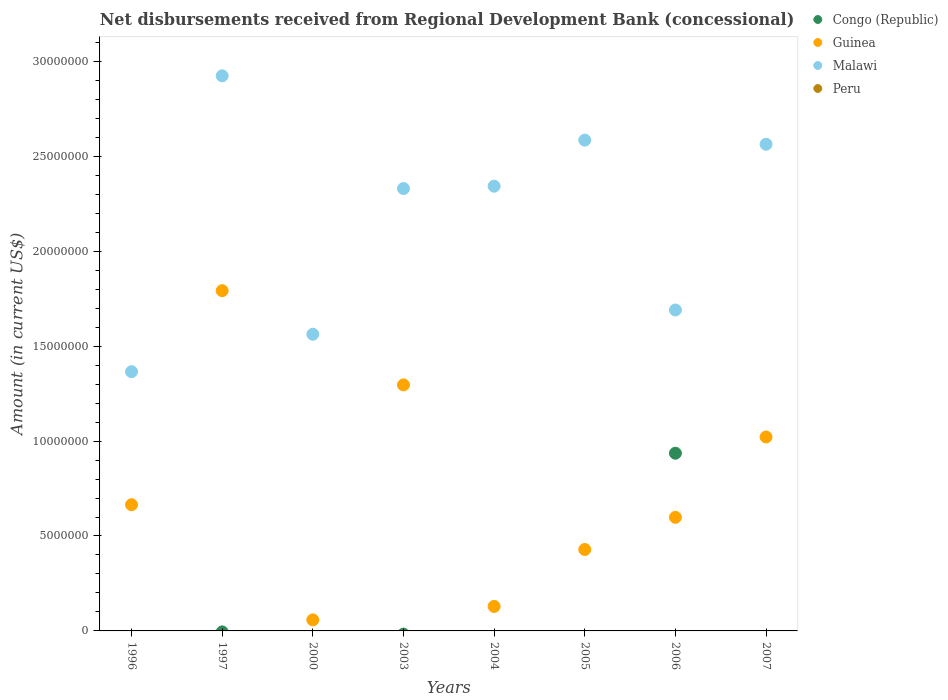What is the amount of disbursements received from Regional Development Bank in Malawi in 2003?
Make the answer very short. 2.33e+07. Across all years, what is the maximum amount of disbursements received from Regional Development Bank in Guinea?
Ensure brevity in your answer.  1.79e+07. What is the total amount of disbursements received from Regional Development Bank in Guinea in the graph?
Offer a very short reply. 5.99e+07. What is the difference between the amount of disbursements received from Regional Development Bank in Malawi in 2003 and that in 2004?
Ensure brevity in your answer.  -1.25e+05. What is the difference between the amount of disbursements received from Regional Development Bank in Guinea in 2000 and the amount of disbursements received from Regional Development Bank in Congo (Republic) in 1996?
Make the answer very short. 5.82e+05. What is the average amount of disbursements received from Regional Development Bank in Guinea per year?
Provide a short and direct response. 7.49e+06. In the year 2006, what is the difference between the amount of disbursements received from Regional Development Bank in Malawi and amount of disbursements received from Regional Development Bank in Congo (Republic)?
Offer a very short reply. 7.54e+06. In how many years, is the amount of disbursements received from Regional Development Bank in Peru greater than 19000000 US$?
Your answer should be very brief. 0. What is the ratio of the amount of disbursements received from Regional Development Bank in Guinea in 2003 to that in 2005?
Offer a terse response. 3.02. What is the difference between the highest and the second highest amount of disbursements received from Regional Development Bank in Guinea?
Ensure brevity in your answer.  4.96e+06. What is the difference between the highest and the lowest amount of disbursements received from Regional Development Bank in Guinea?
Ensure brevity in your answer.  1.73e+07. Is it the case that in every year, the sum of the amount of disbursements received from Regional Development Bank in Congo (Republic) and amount of disbursements received from Regional Development Bank in Malawi  is greater than the sum of amount of disbursements received from Regional Development Bank in Guinea and amount of disbursements received from Regional Development Bank in Peru?
Give a very brief answer. Yes. Is it the case that in every year, the sum of the amount of disbursements received from Regional Development Bank in Peru and amount of disbursements received from Regional Development Bank in Guinea  is greater than the amount of disbursements received from Regional Development Bank in Malawi?
Ensure brevity in your answer.  No. Is the amount of disbursements received from Regional Development Bank in Guinea strictly greater than the amount of disbursements received from Regional Development Bank in Congo (Republic) over the years?
Offer a terse response. No. Does the graph contain any zero values?
Keep it short and to the point. Yes. What is the title of the graph?
Provide a short and direct response. Net disbursements received from Regional Development Bank (concessional). Does "Central African Republic" appear as one of the legend labels in the graph?
Provide a succinct answer. No. What is the label or title of the Y-axis?
Provide a short and direct response. Amount (in current US$). What is the Amount (in current US$) in Congo (Republic) in 1996?
Your answer should be compact. 0. What is the Amount (in current US$) in Guinea in 1996?
Ensure brevity in your answer.  6.65e+06. What is the Amount (in current US$) of Malawi in 1996?
Keep it short and to the point. 1.37e+07. What is the Amount (in current US$) of Congo (Republic) in 1997?
Offer a terse response. 0. What is the Amount (in current US$) in Guinea in 1997?
Give a very brief answer. 1.79e+07. What is the Amount (in current US$) of Malawi in 1997?
Keep it short and to the point. 2.92e+07. What is the Amount (in current US$) in Peru in 1997?
Make the answer very short. 0. What is the Amount (in current US$) of Guinea in 2000?
Your answer should be compact. 5.82e+05. What is the Amount (in current US$) of Malawi in 2000?
Offer a very short reply. 1.56e+07. What is the Amount (in current US$) in Guinea in 2003?
Your response must be concise. 1.30e+07. What is the Amount (in current US$) in Malawi in 2003?
Provide a short and direct response. 2.33e+07. What is the Amount (in current US$) of Congo (Republic) in 2004?
Provide a short and direct response. 0. What is the Amount (in current US$) of Guinea in 2004?
Give a very brief answer. 1.29e+06. What is the Amount (in current US$) of Malawi in 2004?
Make the answer very short. 2.34e+07. What is the Amount (in current US$) of Peru in 2004?
Make the answer very short. 0. What is the Amount (in current US$) in Guinea in 2005?
Keep it short and to the point. 4.29e+06. What is the Amount (in current US$) of Malawi in 2005?
Keep it short and to the point. 2.59e+07. What is the Amount (in current US$) of Congo (Republic) in 2006?
Offer a terse response. 9.36e+06. What is the Amount (in current US$) of Guinea in 2006?
Your answer should be compact. 5.98e+06. What is the Amount (in current US$) of Malawi in 2006?
Offer a very short reply. 1.69e+07. What is the Amount (in current US$) of Peru in 2006?
Offer a terse response. 0. What is the Amount (in current US$) in Guinea in 2007?
Give a very brief answer. 1.02e+07. What is the Amount (in current US$) of Malawi in 2007?
Give a very brief answer. 2.56e+07. Across all years, what is the maximum Amount (in current US$) in Congo (Republic)?
Your answer should be compact. 9.36e+06. Across all years, what is the maximum Amount (in current US$) in Guinea?
Offer a very short reply. 1.79e+07. Across all years, what is the maximum Amount (in current US$) in Malawi?
Ensure brevity in your answer.  2.92e+07. Across all years, what is the minimum Amount (in current US$) in Congo (Republic)?
Offer a terse response. 0. Across all years, what is the minimum Amount (in current US$) of Guinea?
Your answer should be compact. 5.82e+05. Across all years, what is the minimum Amount (in current US$) of Malawi?
Your answer should be compact. 1.37e+07. What is the total Amount (in current US$) in Congo (Republic) in the graph?
Your answer should be compact. 9.36e+06. What is the total Amount (in current US$) in Guinea in the graph?
Offer a terse response. 5.99e+07. What is the total Amount (in current US$) in Malawi in the graph?
Offer a very short reply. 1.74e+08. What is the total Amount (in current US$) in Peru in the graph?
Provide a succinct answer. 0. What is the difference between the Amount (in current US$) in Guinea in 1996 and that in 1997?
Your response must be concise. -1.13e+07. What is the difference between the Amount (in current US$) of Malawi in 1996 and that in 1997?
Provide a succinct answer. -1.56e+07. What is the difference between the Amount (in current US$) in Guinea in 1996 and that in 2000?
Ensure brevity in your answer.  6.06e+06. What is the difference between the Amount (in current US$) in Malawi in 1996 and that in 2000?
Your response must be concise. -1.97e+06. What is the difference between the Amount (in current US$) of Guinea in 1996 and that in 2003?
Ensure brevity in your answer.  -6.31e+06. What is the difference between the Amount (in current US$) in Malawi in 1996 and that in 2003?
Provide a short and direct response. -9.64e+06. What is the difference between the Amount (in current US$) of Guinea in 1996 and that in 2004?
Your answer should be compact. 5.36e+06. What is the difference between the Amount (in current US$) of Malawi in 1996 and that in 2004?
Offer a very short reply. -9.77e+06. What is the difference between the Amount (in current US$) in Guinea in 1996 and that in 2005?
Your response must be concise. 2.36e+06. What is the difference between the Amount (in current US$) in Malawi in 1996 and that in 2005?
Your answer should be very brief. -1.22e+07. What is the difference between the Amount (in current US$) of Guinea in 1996 and that in 2006?
Your answer should be very brief. 6.63e+05. What is the difference between the Amount (in current US$) in Malawi in 1996 and that in 2006?
Make the answer very short. -3.25e+06. What is the difference between the Amount (in current US$) in Guinea in 1996 and that in 2007?
Your answer should be very brief. -3.57e+06. What is the difference between the Amount (in current US$) of Malawi in 1996 and that in 2007?
Your response must be concise. -1.20e+07. What is the difference between the Amount (in current US$) in Guinea in 1997 and that in 2000?
Give a very brief answer. 1.73e+07. What is the difference between the Amount (in current US$) in Malawi in 1997 and that in 2000?
Provide a short and direct response. 1.36e+07. What is the difference between the Amount (in current US$) in Guinea in 1997 and that in 2003?
Ensure brevity in your answer.  4.96e+06. What is the difference between the Amount (in current US$) in Malawi in 1997 and that in 2003?
Provide a succinct answer. 5.94e+06. What is the difference between the Amount (in current US$) of Guinea in 1997 and that in 2004?
Provide a short and direct response. 1.66e+07. What is the difference between the Amount (in current US$) in Malawi in 1997 and that in 2004?
Provide a short and direct response. 5.81e+06. What is the difference between the Amount (in current US$) in Guinea in 1997 and that in 2005?
Provide a short and direct response. 1.36e+07. What is the difference between the Amount (in current US$) in Malawi in 1997 and that in 2005?
Provide a short and direct response. 3.39e+06. What is the difference between the Amount (in current US$) of Guinea in 1997 and that in 2006?
Offer a terse response. 1.19e+07. What is the difference between the Amount (in current US$) in Malawi in 1997 and that in 2006?
Ensure brevity in your answer.  1.23e+07. What is the difference between the Amount (in current US$) in Guinea in 1997 and that in 2007?
Ensure brevity in your answer.  7.71e+06. What is the difference between the Amount (in current US$) of Malawi in 1997 and that in 2007?
Give a very brief answer. 3.60e+06. What is the difference between the Amount (in current US$) of Guinea in 2000 and that in 2003?
Keep it short and to the point. -1.24e+07. What is the difference between the Amount (in current US$) of Malawi in 2000 and that in 2003?
Give a very brief answer. -7.67e+06. What is the difference between the Amount (in current US$) of Guinea in 2000 and that in 2004?
Offer a very short reply. -7.09e+05. What is the difference between the Amount (in current US$) in Malawi in 2000 and that in 2004?
Provide a succinct answer. -7.80e+06. What is the difference between the Amount (in current US$) of Guinea in 2000 and that in 2005?
Make the answer very short. -3.71e+06. What is the difference between the Amount (in current US$) in Malawi in 2000 and that in 2005?
Your answer should be very brief. -1.02e+07. What is the difference between the Amount (in current US$) of Guinea in 2000 and that in 2006?
Provide a short and direct response. -5.40e+06. What is the difference between the Amount (in current US$) of Malawi in 2000 and that in 2006?
Provide a short and direct response. -1.28e+06. What is the difference between the Amount (in current US$) in Guinea in 2000 and that in 2007?
Provide a short and direct response. -9.63e+06. What is the difference between the Amount (in current US$) in Malawi in 2000 and that in 2007?
Offer a terse response. -1.00e+07. What is the difference between the Amount (in current US$) of Guinea in 2003 and that in 2004?
Your response must be concise. 1.17e+07. What is the difference between the Amount (in current US$) in Malawi in 2003 and that in 2004?
Ensure brevity in your answer.  -1.25e+05. What is the difference between the Amount (in current US$) in Guinea in 2003 and that in 2005?
Keep it short and to the point. 8.67e+06. What is the difference between the Amount (in current US$) in Malawi in 2003 and that in 2005?
Keep it short and to the point. -2.55e+06. What is the difference between the Amount (in current US$) of Guinea in 2003 and that in 2006?
Provide a succinct answer. 6.98e+06. What is the difference between the Amount (in current US$) of Malawi in 2003 and that in 2006?
Ensure brevity in your answer.  6.40e+06. What is the difference between the Amount (in current US$) in Guinea in 2003 and that in 2007?
Ensure brevity in your answer.  2.74e+06. What is the difference between the Amount (in current US$) of Malawi in 2003 and that in 2007?
Your answer should be compact. -2.33e+06. What is the difference between the Amount (in current US$) in Guinea in 2004 and that in 2005?
Offer a very short reply. -3.00e+06. What is the difference between the Amount (in current US$) in Malawi in 2004 and that in 2005?
Give a very brief answer. -2.43e+06. What is the difference between the Amount (in current US$) of Guinea in 2004 and that in 2006?
Your response must be concise. -4.69e+06. What is the difference between the Amount (in current US$) of Malawi in 2004 and that in 2006?
Your answer should be very brief. 6.52e+06. What is the difference between the Amount (in current US$) in Guinea in 2004 and that in 2007?
Ensure brevity in your answer.  -8.92e+06. What is the difference between the Amount (in current US$) in Malawi in 2004 and that in 2007?
Give a very brief answer. -2.21e+06. What is the difference between the Amount (in current US$) of Guinea in 2005 and that in 2006?
Provide a succinct answer. -1.70e+06. What is the difference between the Amount (in current US$) in Malawi in 2005 and that in 2006?
Offer a terse response. 8.95e+06. What is the difference between the Amount (in current US$) in Guinea in 2005 and that in 2007?
Make the answer very short. -5.93e+06. What is the difference between the Amount (in current US$) of Malawi in 2005 and that in 2007?
Your answer should be compact. 2.18e+05. What is the difference between the Amount (in current US$) in Guinea in 2006 and that in 2007?
Your answer should be compact. -4.23e+06. What is the difference between the Amount (in current US$) of Malawi in 2006 and that in 2007?
Provide a succinct answer. -8.73e+06. What is the difference between the Amount (in current US$) in Guinea in 1996 and the Amount (in current US$) in Malawi in 1997?
Offer a very short reply. -2.26e+07. What is the difference between the Amount (in current US$) of Guinea in 1996 and the Amount (in current US$) of Malawi in 2000?
Ensure brevity in your answer.  -8.98e+06. What is the difference between the Amount (in current US$) in Guinea in 1996 and the Amount (in current US$) in Malawi in 2003?
Your answer should be compact. -1.67e+07. What is the difference between the Amount (in current US$) in Guinea in 1996 and the Amount (in current US$) in Malawi in 2004?
Ensure brevity in your answer.  -1.68e+07. What is the difference between the Amount (in current US$) in Guinea in 1996 and the Amount (in current US$) in Malawi in 2005?
Your answer should be compact. -1.92e+07. What is the difference between the Amount (in current US$) in Guinea in 1996 and the Amount (in current US$) in Malawi in 2006?
Provide a succinct answer. -1.03e+07. What is the difference between the Amount (in current US$) of Guinea in 1996 and the Amount (in current US$) of Malawi in 2007?
Make the answer very short. -1.90e+07. What is the difference between the Amount (in current US$) of Guinea in 1997 and the Amount (in current US$) of Malawi in 2000?
Your answer should be compact. 2.30e+06. What is the difference between the Amount (in current US$) in Guinea in 1997 and the Amount (in current US$) in Malawi in 2003?
Your answer should be very brief. -5.38e+06. What is the difference between the Amount (in current US$) in Guinea in 1997 and the Amount (in current US$) in Malawi in 2004?
Offer a very short reply. -5.50e+06. What is the difference between the Amount (in current US$) of Guinea in 1997 and the Amount (in current US$) of Malawi in 2005?
Give a very brief answer. -7.93e+06. What is the difference between the Amount (in current US$) in Guinea in 1997 and the Amount (in current US$) in Malawi in 2006?
Offer a terse response. 1.02e+06. What is the difference between the Amount (in current US$) in Guinea in 1997 and the Amount (in current US$) in Malawi in 2007?
Provide a short and direct response. -7.71e+06. What is the difference between the Amount (in current US$) in Guinea in 2000 and the Amount (in current US$) in Malawi in 2003?
Your answer should be very brief. -2.27e+07. What is the difference between the Amount (in current US$) of Guinea in 2000 and the Amount (in current US$) of Malawi in 2004?
Offer a terse response. -2.28e+07. What is the difference between the Amount (in current US$) in Guinea in 2000 and the Amount (in current US$) in Malawi in 2005?
Your answer should be compact. -2.53e+07. What is the difference between the Amount (in current US$) of Guinea in 2000 and the Amount (in current US$) of Malawi in 2006?
Provide a succinct answer. -1.63e+07. What is the difference between the Amount (in current US$) in Guinea in 2000 and the Amount (in current US$) in Malawi in 2007?
Your answer should be compact. -2.51e+07. What is the difference between the Amount (in current US$) in Guinea in 2003 and the Amount (in current US$) in Malawi in 2004?
Make the answer very short. -1.05e+07. What is the difference between the Amount (in current US$) in Guinea in 2003 and the Amount (in current US$) in Malawi in 2005?
Provide a succinct answer. -1.29e+07. What is the difference between the Amount (in current US$) of Guinea in 2003 and the Amount (in current US$) of Malawi in 2006?
Give a very brief answer. -3.94e+06. What is the difference between the Amount (in current US$) of Guinea in 2003 and the Amount (in current US$) of Malawi in 2007?
Offer a terse response. -1.27e+07. What is the difference between the Amount (in current US$) of Guinea in 2004 and the Amount (in current US$) of Malawi in 2005?
Offer a terse response. -2.46e+07. What is the difference between the Amount (in current US$) of Guinea in 2004 and the Amount (in current US$) of Malawi in 2006?
Make the answer very short. -1.56e+07. What is the difference between the Amount (in current US$) of Guinea in 2004 and the Amount (in current US$) of Malawi in 2007?
Offer a very short reply. -2.43e+07. What is the difference between the Amount (in current US$) in Guinea in 2005 and the Amount (in current US$) in Malawi in 2006?
Make the answer very short. -1.26e+07. What is the difference between the Amount (in current US$) of Guinea in 2005 and the Amount (in current US$) of Malawi in 2007?
Make the answer very short. -2.13e+07. What is the difference between the Amount (in current US$) of Congo (Republic) in 2006 and the Amount (in current US$) of Guinea in 2007?
Give a very brief answer. -8.54e+05. What is the difference between the Amount (in current US$) in Congo (Republic) in 2006 and the Amount (in current US$) in Malawi in 2007?
Provide a short and direct response. -1.63e+07. What is the difference between the Amount (in current US$) in Guinea in 2006 and the Amount (in current US$) in Malawi in 2007?
Provide a short and direct response. -1.97e+07. What is the average Amount (in current US$) of Congo (Republic) per year?
Offer a terse response. 1.17e+06. What is the average Amount (in current US$) in Guinea per year?
Your response must be concise. 7.49e+06. What is the average Amount (in current US$) in Malawi per year?
Your answer should be compact. 2.17e+07. In the year 1996, what is the difference between the Amount (in current US$) of Guinea and Amount (in current US$) of Malawi?
Offer a terse response. -7.01e+06. In the year 1997, what is the difference between the Amount (in current US$) in Guinea and Amount (in current US$) in Malawi?
Offer a terse response. -1.13e+07. In the year 2000, what is the difference between the Amount (in current US$) in Guinea and Amount (in current US$) in Malawi?
Your answer should be very brief. -1.50e+07. In the year 2003, what is the difference between the Amount (in current US$) in Guinea and Amount (in current US$) in Malawi?
Provide a short and direct response. -1.03e+07. In the year 2004, what is the difference between the Amount (in current US$) of Guinea and Amount (in current US$) of Malawi?
Your answer should be very brief. -2.21e+07. In the year 2005, what is the difference between the Amount (in current US$) of Guinea and Amount (in current US$) of Malawi?
Make the answer very short. -2.16e+07. In the year 2006, what is the difference between the Amount (in current US$) in Congo (Republic) and Amount (in current US$) in Guinea?
Offer a terse response. 3.38e+06. In the year 2006, what is the difference between the Amount (in current US$) in Congo (Republic) and Amount (in current US$) in Malawi?
Provide a short and direct response. -7.54e+06. In the year 2006, what is the difference between the Amount (in current US$) of Guinea and Amount (in current US$) of Malawi?
Your response must be concise. -1.09e+07. In the year 2007, what is the difference between the Amount (in current US$) in Guinea and Amount (in current US$) in Malawi?
Offer a terse response. -1.54e+07. What is the ratio of the Amount (in current US$) of Guinea in 1996 to that in 1997?
Give a very brief answer. 0.37. What is the ratio of the Amount (in current US$) in Malawi in 1996 to that in 1997?
Provide a succinct answer. 0.47. What is the ratio of the Amount (in current US$) in Guinea in 1996 to that in 2000?
Provide a short and direct response. 11.42. What is the ratio of the Amount (in current US$) of Malawi in 1996 to that in 2000?
Offer a terse response. 0.87. What is the ratio of the Amount (in current US$) of Guinea in 1996 to that in 2003?
Your answer should be compact. 0.51. What is the ratio of the Amount (in current US$) of Malawi in 1996 to that in 2003?
Your answer should be compact. 0.59. What is the ratio of the Amount (in current US$) in Guinea in 1996 to that in 2004?
Ensure brevity in your answer.  5.15. What is the ratio of the Amount (in current US$) of Malawi in 1996 to that in 2004?
Keep it short and to the point. 0.58. What is the ratio of the Amount (in current US$) in Guinea in 1996 to that in 2005?
Offer a terse response. 1.55. What is the ratio of the Amount (in current US$) in Malawi in 1996 to that in 2005?
Keep it short and to the point. 0.53. What is the ratio of the Amount (in current US$) of Guinea in 1996 to that in 2006?
Your answer should be compact. 1.11. What is the ratio of the Amount (in current US$) of Malawi in 1996 to that in 2006?
Offer a terse response. 0.81. What is the ratio of the Amount (in current US$) in Guinea in 1996 to that in 2007?
Your response must be concise. 0.65. What is the ratio of the Amount (in current US$) in Malawi in 1996 to that in 2007?
Give a very brief answer. 0.53. What is the ratio of the Amount (in current US$) of Guinea in 1997 to that in 2000?
Provide a succinct answer. 30.79. What is the ratio of the Amount (in current US$) in Malawi in 1997 to that in 2000?
Your response must be concise. 1.87. What is the ratio of the Amount (in current US$) of Guinea in 1997 to that in 2003?
Offer a terse response. 1.38. What is the ratio of the Amount (in current US$) in Malawi in 1997 to that in 2003?
Your answer should be compact. 1.25. What is the ratio of the Amount (in current US$) in Guinea in 1997 to that in 2004?
Your response must be concise. 13.88. What is the ratio of the Amount (in current US$) in Malawi in 1997 to that in 2004?
Make the answer very short. 1.25. What is the ratio of the Amount (in current US$) in Guinea in 1997 to that in 2005?
Provide a succinct answer. 4.18. What is the ratio of the Amount (in current US$) in Malawi in 1997 to that in 2005?
Give a very brief answer. 1.13. What is the ratio of the Amount (in current US$) of Guinea in 1997 to that in 2006?
Make the answer very short. 3. What is the ratio of the Amount (in current US$) of Malawi in 1997 to that in 2006?
Keep it short and to the point. 1.73. What is the ratio of the Amount (in current US$) of Guinea in 1997 to that in 2007?
Keep it short and to the point. 1.75. What is the ratio of the Amount (in current US$) of Malawi in 1997 to that in 2007?
Provide a short and direct response. 1.14. What is the ratio of the Amount (in current US$) of Guinea in 2000 to that in 2003?
Provide a short and direct response. 0.04. What is the ratio of the Amount (in current US$) in Malawi in 2000 to that in 2003?
Keep it short and to the point. 0.67. What is the ratio of the Amount (in current US$) of Guinea in 2000 to that in 2004?
Offer a terse response. 0.45. What is the ratio of the Amount (in current US$) in Malawi in 2000 to that in 2004?
Give a very brief answer. 0.67. What is the ratio of the Amount (in current US$) of Guinea in 2000 to that in 2005?
Your response must be concise. 0.14. What is the ratio of the Amount (in current US$) of Malawi in 2000 to that in 2005?
Make the answer very short. 0.6. What is the ratio of the Amount (in current US$) in Guinea in 2000 to that in 2006?
Ensure brevity in your answer.  0.1. What is the ratio of the Amount (in current US$) of Malawi in 2000 to that in 2006?
Offer a terse response. 0.92. What is the ratio of the Amount (in current US$) in Guinea in 2000 to that in 2007?
Your answer should be very brief. 0.06. What is the ratio of the Amount (in current US$) in Malawi in 2000 to that in 2007?
Your answer should be compact. 0.61. What is the ratio of the Amount (in current US$) of Guinea in 2003 to that in 2004?
Your response must be concise. 10.04. What is the ratio of the Amount (in current US$) in Guinea in 2003 to that in 2005?
Your answer should be compact. 3.02. What is the ratio of the Amount (in current US$) in Malawi in 2003 to that in 2005?
Your answer should be very brief. 0.9. What is the ratio of the Amount (in current US$) of Guinea in 2003 to that in 2006?
Your answer should be very brief. 2.17. What is the ratio of the Amount (in current US$) of Malawi in 2003 to that in 2006?
Provide a succinct answer. 1.38. What is the ratio of the Amount (in current US$) in Guinea in 2003 to that in 2007?
Your answer should be compact. 1.27. What is the ratio of the Amount (in current US$) of Malawi in 2003 to that in 2007?
Provide a short and direct response. 0.91. What is the ratio of the Amount (in current US$) in Guinea in 2004 to that in 2005?
Provide a short and direct response. 0.3. What is the ratio of the Amount (in current US$) of Malawi in 2004 to that in 2005?
Provide a short and direct response. 0.91. What is the ratio of the Amount (in current US$) in Guinea in 2004 to that in 2006?
Provide a short and direct response. 0.22. What is the ratio of the Amount (in current US$) in Malawi in 2004 to that in 2006?
Give a very brief answer. 1.39. What is the ratio of the Amount (in current US$) in Guinea in 2004 to that in 2007?
Your answer should be compact. 0.13. What is the ratio of the Amount (in current US$) of Malawi in 2004 to that in 2007?
Give a very brief answer. 0.91. What is the ratio of the Amount (in current US$) of Guinea in 2005 to that in 2006?
Provide a short and direct response. 0.72. What is the ratio of the Amount (in current US$) in Malawi in 2005 to that in 2006?
Offer a very short reply. 1.53. What is the ratio of the Amount (in current US$) in Guinea in 2005 to that in 2007?
Your answer should be compact. 0.42. What is the ratio of the Amount (in current US$) in Malawi in 2005 to that in 2007?
Offer a terse response. 1.01. What is the ratio of the Amount (in current US$) in Guinea in 2006 to that in 2007?
Your answer should be compact. 0.59. What is the ratio of the Amount (in current US$) in Malawi in 2006 to that in 2007?
Offer a terse response. 0.66. What is the difference between the highest and the second highest Amount (in current US$) of Guinea?
Provide a succinct answer. 4.96e+06. What is the difference between the highest and the second highest Amount (in current US$) of Malawi?
Your answer should be very brief. 3.39e+06. What is the difference between the highest and the lowest Amount (in current US$) of Congo (Republic)?
Keep it short and to the point. 9.36e+06. What is the difference between the highest and the lowest Amount (in current US$) of Guinea?
Give a very brief answer. 1.73e+07. What is the difference between the highest and the lowest Amount (in current US$) in Malawi?
Offer a very short reply. 1.56e+07. 